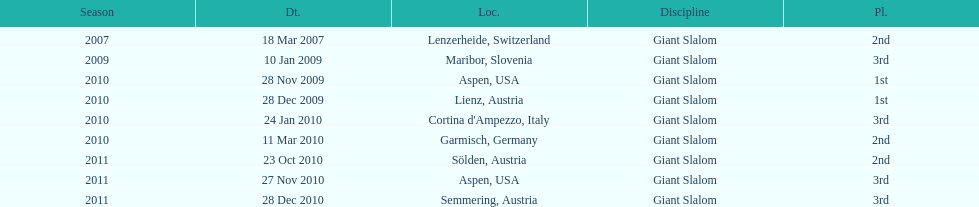Would you mind parsing the complete table? {'header': ['Season', 'Dt.', 'Loc.', 'Discipline', 'Pl.'], 'rows': [['2007', '18 Mar 2007', 'Lenzerheide, Switzerland', 'Giant Slalom', '2nd'], ['2009', '10 Jan 2009', 'Maribor, Slovenia', 'Giant Slalom', '3rd'], ['2010', '28 Nov 2009', 'Aspen, USA', 'Giant Slalom', '1st'], ['2010', '28 Dec 2009', 'Lienz, Austria', 'Giant Slalom', '1st'], ['2010', '24 Jan 2010', "Cortina d'Ampezzo, Italy", 'Giant Slalom', '3rd'], ['2010', '11 Mar 2010', 'Garmisch, Germany', 'Giant Slalom', '2nd'], ['2011', '23 Oct 2010', 'Sölden, Austria', 'Giant Slalom', '2nd'], ['2011', '27 Nov 2010', 'Aspen, USA', 'Giant Slalom', '3rd'], ['2011', '28 Dec 2010', 'Semmering, Austria', 'Giant Slalom', '3rd']]} What is the total number of her 2nd place finishes on the list? 3. 